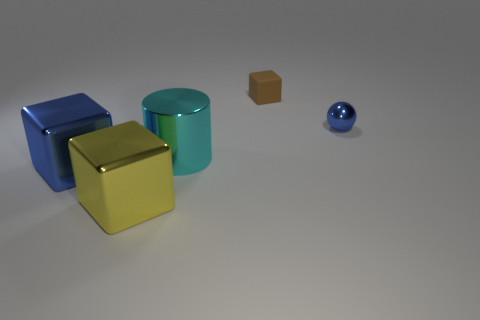Subtract all matte blocks. How many blocks are left? 2 Add 5 cyan cylinders. How many objects exist? 10 Subtract all balls. How many objects are left? 4 Add 1 blue objects. How many blue objects are left? 3 Add 4 cyan things. How many cyan things exist? 5 Subtract 0 green cylinders. How many objects are left? 5 Subtract all small brown matte cubes. Subtract all blocks. How many objects are left? 1 